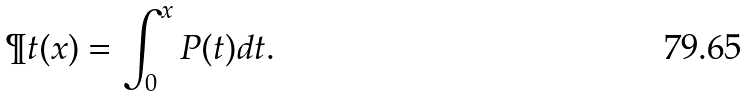Convert formula to latex. <formula><loc_0><loc_0><loc_500><loc_500>\P t ( x ) = \int _ { 0 } ^ { x } P ( t ) d t .</formula> 